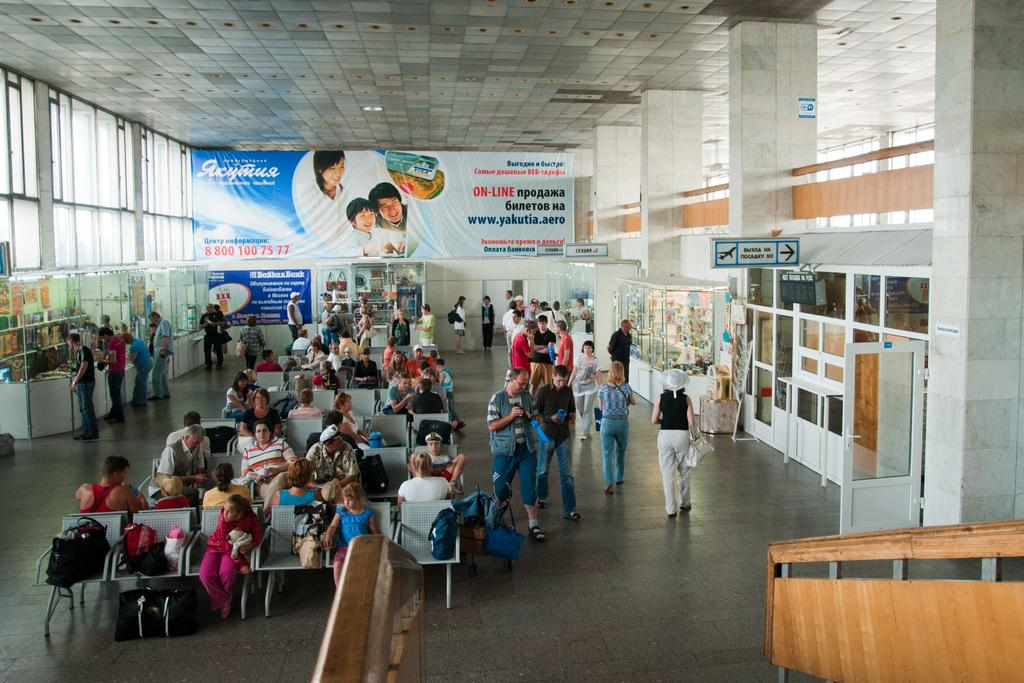How many people are in the image? There are people in the image, but the exact number is not specified. What objects are present in the image that people might sit on? There are chairs in the image that people might sit on. What items can be seen that people might carry? There are bags in the image that people might carry. What type of decorations are present in the image? There are banners in the image as decorations. What type of signage is present in the image? There are sign boards in the image. What are some of the people in the image doing? Some people are walking, and some people are sitting on chairs. What type of architectural feature is visible in the image? There are glass windows in the image. Can you see a throne in the image? No, there is no throne present in the image. Are there any tails visible in the image? No, there are no tails visible in the image. 